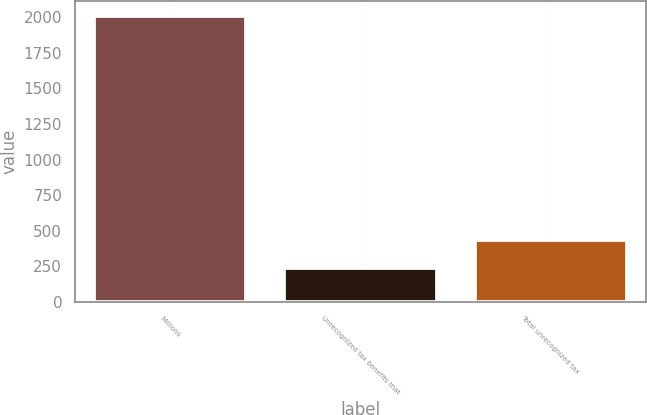<chart> <loc_0><loc_0><loc_500><loc_500><bar_chart><fcel>Millions<fcel>Unrecognized tax benefits that<fcel>Total unrecognized tax<nl><fcel>2012<fcel>238.1<fcel>435.2<nl></chart> 